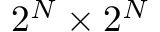Convert formula to latex. <formula><loc_0><loc_0><loc_500><loc_500>2 ^ { N } \times 2 ^ { N }</formula> 